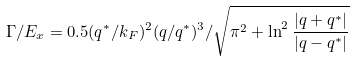<formula> <loc_0><loc_0><loc_500><loc_500>\Gamma / E _ { x } = 0 . 5 ( q ^ { * } / k _ { F } ) ^ { 2 } ( q / q ^ { * } ) ^ { 3 } / \sqrt { \pi ^ { 2 } + \ln ^ { 2 } \frac { | q + q ^ { * } | } { | q - q ^ { * } | } }</formula> 